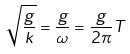Convert formula to latex. <formula><loc_0><loc_0><loc_500><loc_500>\sqrt { \frac { g } { k } } = \frac { g } { \omega } = \frac { g } { 2 \pi } T</formula> 